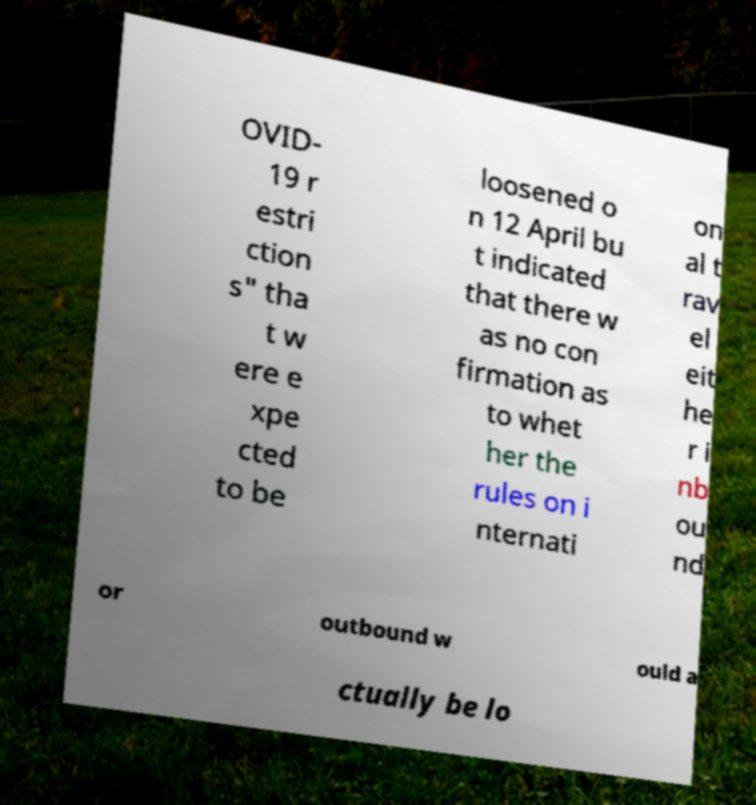Please read and relay the text visible in this image. What does it say? OVID- 19 r estri ction s" tha t w ere e xpe cted to be loosened o n 12 April bu t indicated that there w as no con firmation as to whet her the rules on i nternati on al t rav el eit he r i nb ou nd or outbound w ould a ctually be lo 